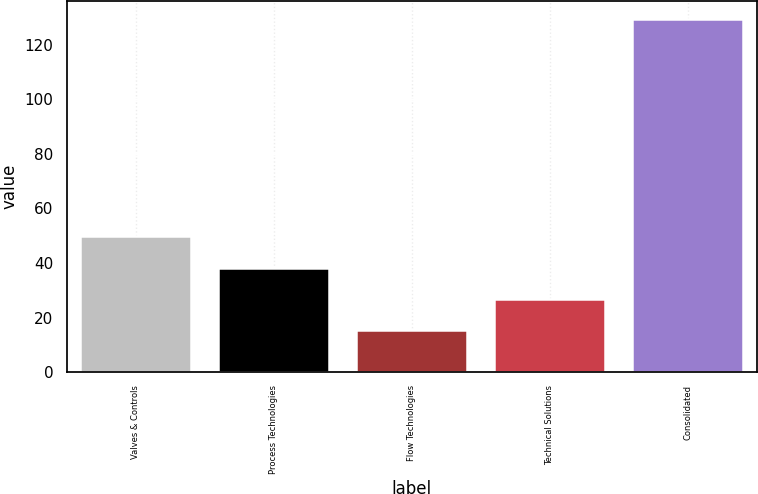Convert chart. <chart><loc_0><loc_0><loc_500><loc_500><bar_chart><fcel>Valves & Controls<fcel>Process Technologies<fcel>Flow Technologies<fcel>Technical Solutions<fcel>Consolidated<nl><fcel>49.73<fcel>38.32<fcel>15.5<fcel>26.91<fcel>129.6<nl></chart> 